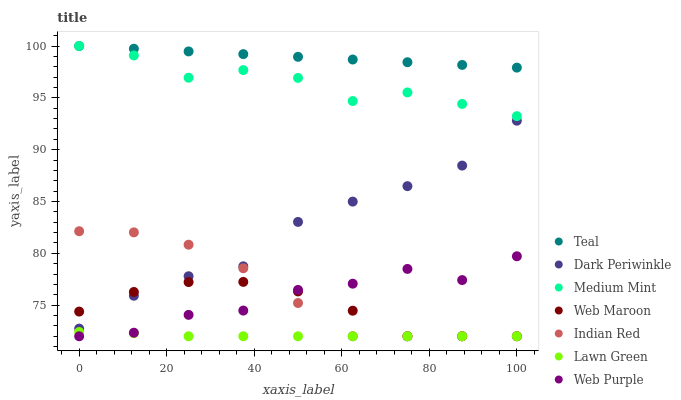Does Lawn Green have the minimum area under the curve?
Answer yes or no. Yes. Does Teal have the maximum area under the curve?
Answer yes or no. Yes. Does Teal have the minimum area under the curve?
Answer yes or no. No. Does Lawn Green have the maximum area under the curve?
Answer yes or no. No. Is Teal the smoothest?
Answer yes or no. Yes. Is Web Purple the roughest?
Answer yes or no. Yes. Is Lawn Green the smoothest?
Answer yes or no. No. Is Lawn Green the roughest?
Answer yes or no. No. Does Lawn Green have the lowest value?
Answer yes or no. Yes. Does Teal have the lowest value?
Answer yes or no. No. Does Teal have the highest value?
Answer yes or no. Yes. Does Lawn Green have the highest value?
Answer yes or no. No. Is Web Purple less than Dark Periwinkle?
Answer yes or no. Yes. Is Dark Periwinkle greater than Web Purple?
Answer yes or no. Yes. Does Web Maroon intersect Lawn Green?
Answer yes or no. Yes. Is Web Maroon less than Lawn Green?
Answer yes or no. No. Is Web Maroon greater than Lawn Green?
Answer yes or no. No. Does Web Purple intersect Dark Periwinkle?
Answer yes or no. No. 